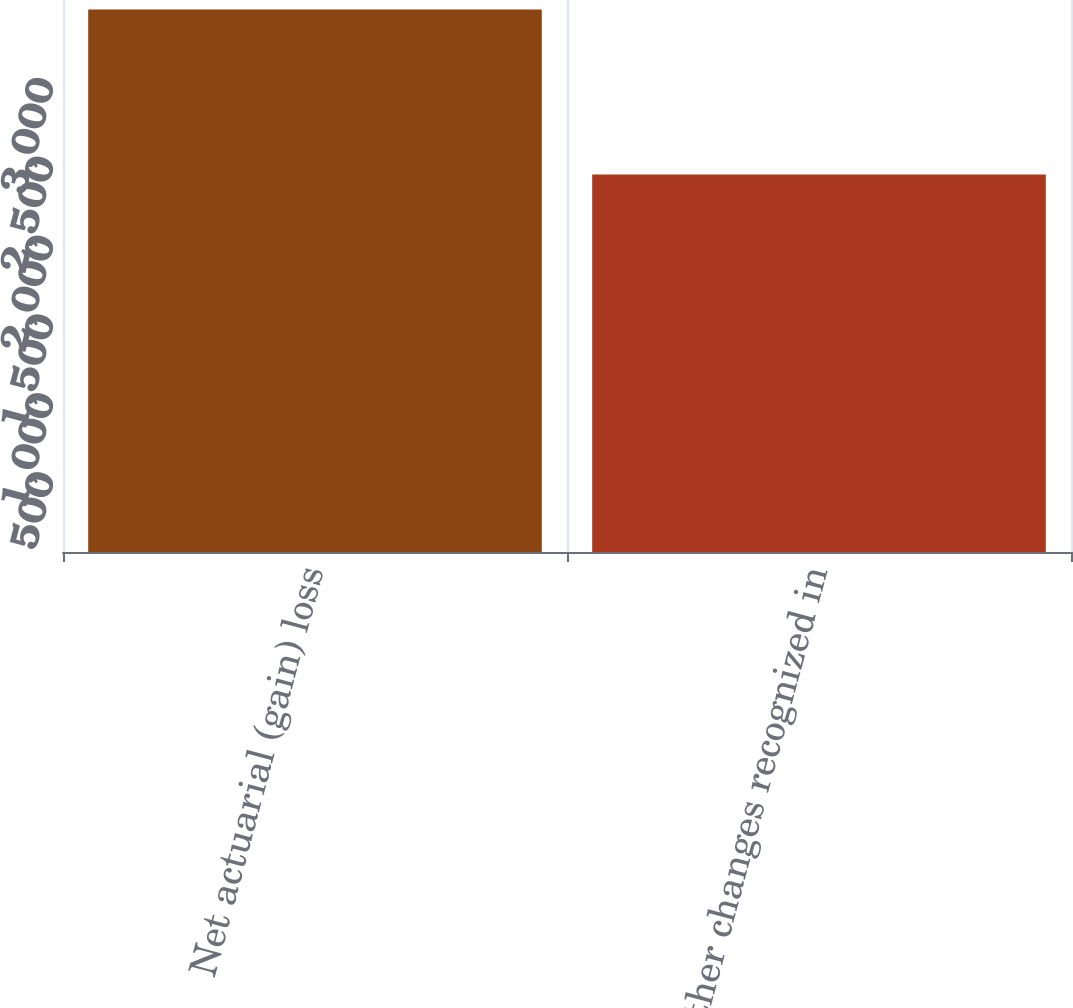Convert chart to OTSL. <chart><loc_0><loc_0><loc_500><loc_500><bar_chart><fcel>Net actuarial (gain) loss<fcel>Other changes recognized in<nl><fcel>3439<fcel>2393<nl></chart> 